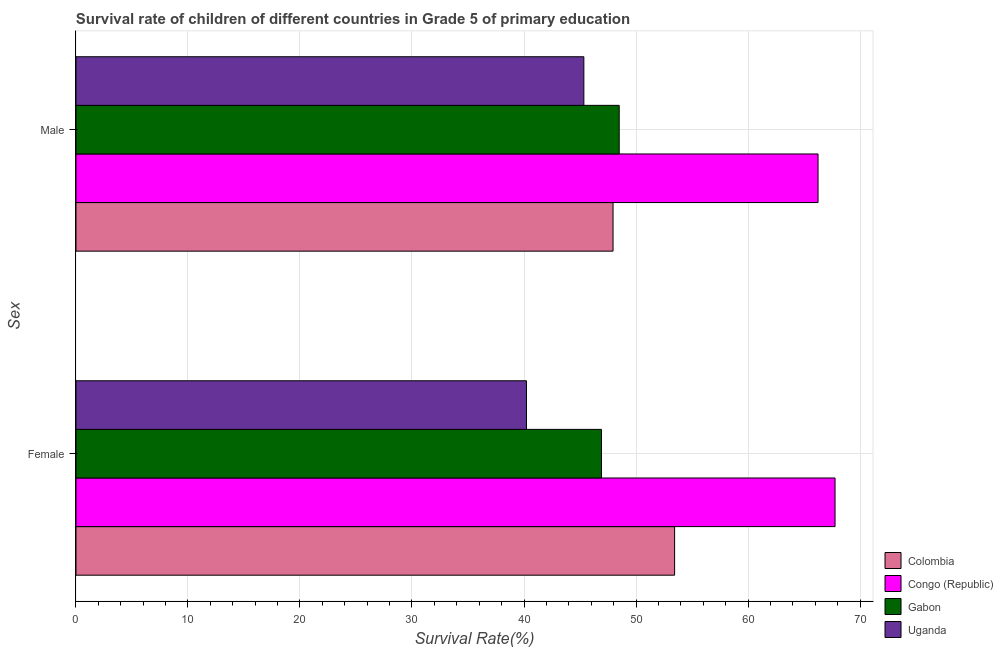How many bars are there on the 2nd tick from the top?
Keep it short and to the point. 4. What is the survival rate of male students in primary education in Congo (Republic)?
Make the answer very short. 66.25. Across all countries, what is the maximum survival rate of male students in primary education?
Keep it short and to the point. 66.25. Across all countries, what is the minimum survival rate of female students in primary education?
Keep it short and to the point. 40.22. In which country was the survival rate of male students in primary education maximum?
Provide a succinct answer. Congo (Republic). In which country was the survival rate of female students in primary education minimum?
Provide a succinct answer. Uganda. What is the total survival rate of male students in primary education in the graph?
Your answer should be very brief. 208.05. What is the difference between the survival rate of female students in primary education in Colombia and that in Congo (Republic)?
Keep it short and to the point. -14.33. What is the difference between the survival rate of female students in primary education in Congo (Republic) and the survival rate of male students in primary education in Colombia?
Give a very brief answer. 19.82. What is the average survival rate of female students in primary education per country?
Ensure brevity in your answer.  52.09. What is the difference between the survival rate of female students in primary education and survival rate of male students in primary education in Uganda?
Keep it short and to the point. -5.12. In how many countries, is the survival rate of male students in primary education greater than 22 %?
Provide a short and direct response. 4. What is the ratio of the survival rate of female students in primary education in Gabon to that in Colombia?
Make the answer very short. 0.88. Is the survival rate of male students in primary education in Uganda less than that in Gabon?
Offer a terse response. Yes. In how many countries, is the survival rate of male students in primary education greater than the average survival rate of male students in primary education taken over all countries?
Your response must be concise. 1. What does the 4th bar from the top in Male represents?
Keep it short and to the point. Colombia. What does the 3rd bar from the bottom in Female represents?
Make the answer very short. Gabon. How many bars are there?
Ensure brevity in your answer.  8. Are all the bars in the graph horizontal?
Your answer should be compact. Yes. Are the values on the major ticks of X-axis written in scientific E-notation?
Provide a short and direct response. No. Does the graph contain grids?
Make the answer very short. Yes. How many legend labels are there?
Make the answer very short. 4. How are the legend labels stacked?
Provide a short and direct response. Vertical. What is the title of the graph?
Provide a succinct answer. Survival rate of children of different countries in Grade 5 of primary education. What is the label or title of the X-axis?
Give a very brief answer. Survival Rate(%). What is the label or title of the Y-axis?
Your answer should be very brief. Sex. What is the Survival Rate(%) of Colombia in Female?
Your response must be concise. 53.45. What is the Survival Rate(%) in Congo (Republic) in Female?
Make the answer very short. 67.77. What is the Survival Rate(%) of Gabon in Female?
Your answer should be compact. 46.92. What is the Survival Rate(%) in Uganda in Female?
Offer a terse response. 40.22. What is the Survival Rate(%) in Colombia in Male?
Your answer should be compact. 47.95. What is the Survival Rate(%) of Congo (Republic) in Male?
Provide a succinct answer. 66.25. What is the Survival Rate(%) of Gabon in Male?
Ensure brevity in your answer.  48.5. What is the Survival Rate(%) in Uganda in Male?
Your response must be concise. 45.34. Across all Sex, what is the maximum Survival Rate(%) of Colombia?
Make the answer very short. 53.45. Across all Sex, what is the maximum Survival Rate(%) in Congo (Republic)?
Ensure brevity in your answer.  67.77. Across all Sex, what is the maximum Survival Rate(%) of Gabon?
Make the answer very short. 48.5. Across all Sex, what is the maximum Survival Rate(%) of Uganda?
Provide a succinct answer. 45.34. Across all Sex, what is the minimum Survival Rate(%) in Colombia?
Give a very brief answer. 47.95. Across all Sex, what is the minimum Survival Rate(%) of Congo (Republic)?
Your response must be concise. 66.25. Across all Sex, what is the minimum Survival Rate(%) of Gabon?
Your answer should be very brief. 46.92. Across all Sex, what is the minimum Survival Rate(%) of Uganda?
Your answer should be very brief. 40.22. What is the total Survival Rate(%) of Colombia in the graph?
Your response must be concise. 101.4. What is the total Survival Rate(%) in Congo (Republic) in the graph?
Make the answer very short. 134.03. What is the total Survival Rate(%) in Gabon in the graph?
Ensure brevity in your answer.  95.42. What is the total Survival Rate(%) in Uganda in the graph?
Give a very brief answer. 85.57. What is the difference between the Survival Rate(%) in Colombia in Female and that in Male?
Give a very brief answer. 5.5. What is the difference between the Survival Rate(%) of Congo (Republic) in Female and that in Male?
Keep it short and to the point. 1.52. What is the difference between the Survival Rate(%) in Gabon in Female and that in Male?
Provide a short and direct response. -1.58. What is the difference between the Survival Rate(%) in Uganda in Female and that in Male?
Give a very brief answer. -5.12. What is the difference between the Survival Rate(%) of Colombia in Female and the Survival Rate(%) of Congo (Republic) in Male?
Provide a short and direct response. -12.81. What is the difference between the Survival Rate(%) in Colombia in Female and the Survival Rate(%) in Gabon in Male?
Provide a succinct answer. 4.95. What is the difference between the Survival Rate(%) in Colombia in Female and the Survival Rate(%) in Uganda in Male?
Provide a short and direct response. 8.1. What is the difference between the Survival Rate(%) of Congo (Republic) in Female and the Survival Rate(%) of Gabon in Male?
Your answer should be very brief. 19.27. What is the difference between the Survival Rate(%) in Congo (Republic) in Female and the Survival Rate(%) in Uganda in Male?
Ensure brevity in your answer.  22.43. What is the difference between the Survival Rate(%) in Gabon in Female and the Survival Rate(%) in Uganda in Male?
Your response must be concise. 1.57. What is the average Survival Rate(%) of Colombia per Sex?
Offer a terse response. 50.7. What is the average Survival Rate(%) of Congo (Republic) per Sex?
Your response must be concise. 67.01. What is the average Survival Rate(%) of Gabon per Sex?
Your response must be concise. 47.71. What is the average Survival Rate(%) in Uganda per Sex?
Give a very brief answer. 42.78. What is the difference between the Survival Rate(%) of Colombia and Survival Rate(%) of Congo (Republic) in Female?
Your answer should be compact. -14.33. What is the difference between the Survival Rate(%) in Colombia and Survival Rate(%) in Gabon in Female?
Your answer should be compact. 6.53. What is the difference between the Survival Rate(%) of Colombia and Survival Rate(%) of Uganda in Female?
Ensure brevity in your answer.  13.23. What is the difference between the Survival Rate(%) of Congo (Republic) and Survival Rate(%) of Gabon in Female?
Your answer should be very brief. 20.86. What is the difference between the Survival Rate(%) of Congo (Republic) and Survival Rate(%) of Uganda in Female?
Provide a short and direct response. 27.55. What is the difference between the Survival Rate(%) in Gabon and Survival Rate(%) in Uganda in Female?
Offer a very short reply. 6.7. What is the difference between the Survival Rate(%) of Colombia and Survival Rate(%) of Congo (Republic) in Male?
Your answer should be very brief. -18.3. What is the difference between the Survival Rate(%) of Colombia and Survival Rate(%) of Gabon in Male?
Provide a short and direct response. -0.55. What is the difference between the Survival Rate(%) in Colombia and Survival Rate(%) in Uganda in Male?
Your answer should be compact. 2.61. What is the difference between the Survival Rate(%) of Congo (Republic) and Survival Rate(%) of Gabon in Male?
Provide a succinct answer. 17.75. What is the difference between the Survival Rate(%) of Congo (Republic) and Survival Rate(%) of Uganda in Male?
Your answer should be very brief. 20.91. What is the difference between the Survival Rate(%) of Gabon and Survival Rate(%) of Uganda in Male?
Give a very brief answer. 3.16. What is the ratio of the Survival Rate(%) in Colombia in Female to that in Male?
Your response must be concise. 1.11. What is the ratio of the Survival Rate(%) of Congo (Republic) in Female to that in Male?
Give a very brief answer. 1.02. What is the ratio of the Survival Rate(%) in Gabon in Female to that in Male?
Your response must be concise. 0.97. What is the ratio of the Survival Rate(%) in Uganda in Female to that in Male?
Make the answer very short. 0.89. What is the difference between the highest and the second highest Survival Rate(%) of Colombia?
Offer a terse response. 5.5. What is the difference between the highest and the second highest Survival Rate(%) of Congo (Republic)?
Give a very brief answer. 1.52. What is the difference between the highest and the second highest Survival Rate(%) of Gabon?
Provide a short and direct response. 1.58. What is the difference between the highest and the second highest Survival Rate(%) of Uganda?
Offer a terse response. 5.12. What is the difference between the highest and the lowest Survival Rate(%) in Colombia?
Your response must be concise. 5.5. What is the difference between the highest and the lowest Survival Rate(%) in Congo (Republic)?
Provide a succinct answer. 1.52. What is the difference between the highest and the lowest Survival Rate(%) of Gabon?
Ensure brevity in your answer.  1.58. What is the difference between the highest and the lowest Survival Rate(%) of Uganda?
Provide a short and direct response. 5.12. 